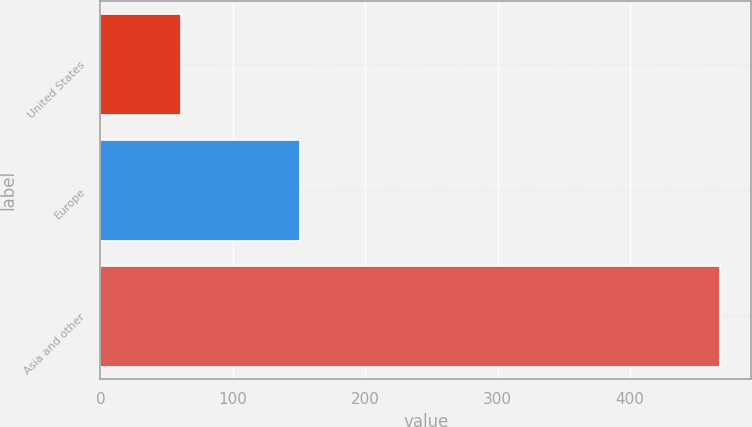<chart> <loc_0><loc_0><loc_500><loc_500><bar_chart><fcel>United States<fcel>Europe<fcel>Asia and other<nl><fcel>61<fcel>151<fcel>468<nl></chart> 